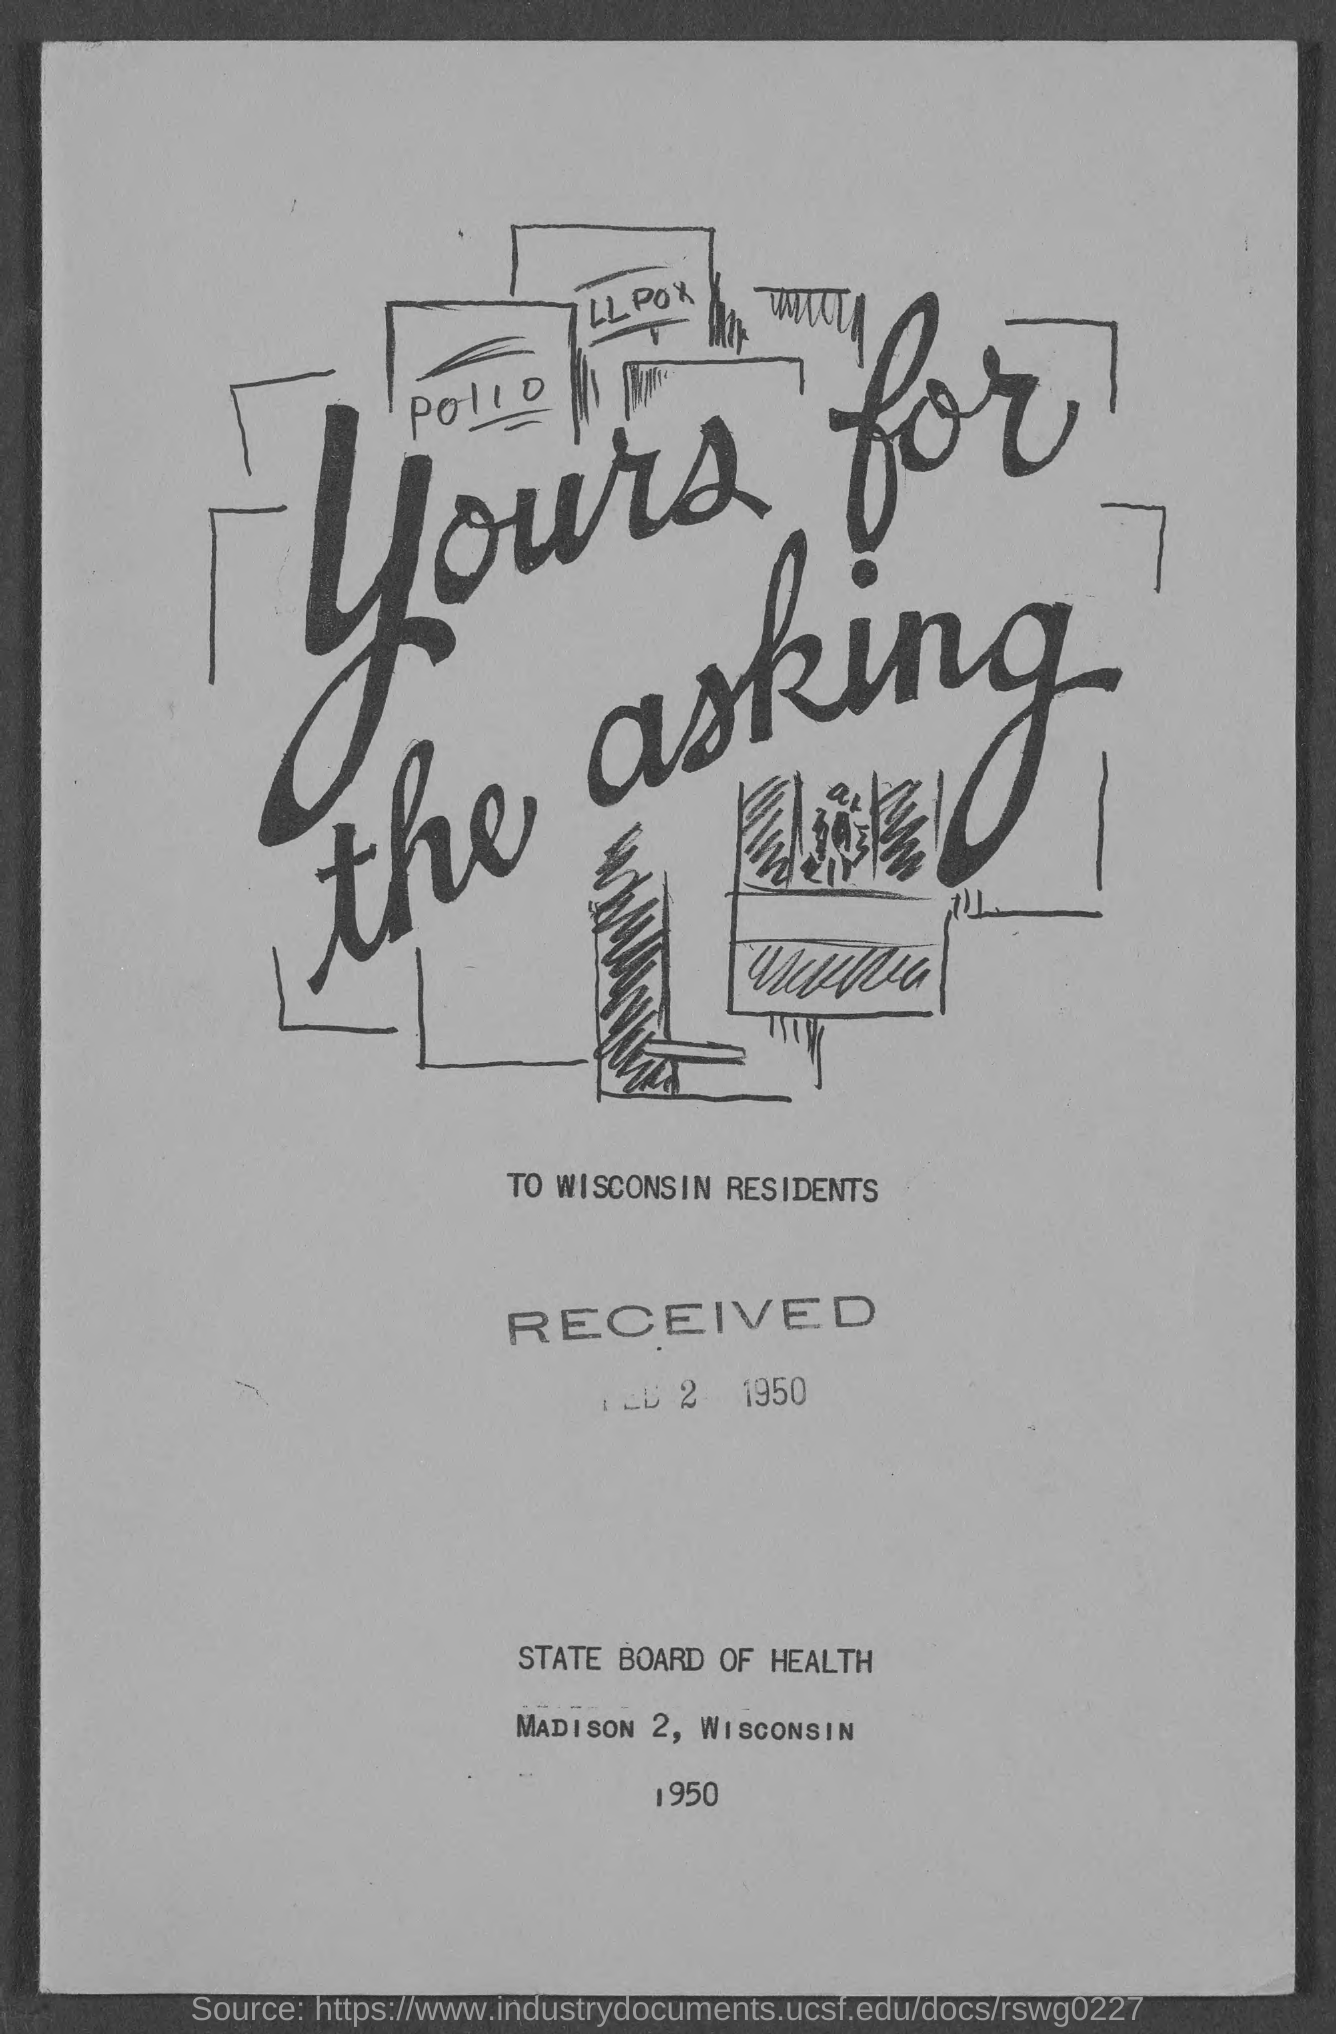Which residents are mentioned?
Give a very brief answer. WISCONSIN RESIDENTS. When was the document received?
Your response must be concise. FEB 2  1950. Which is the year mentioned at the bottom?
Provide a short and direct response. 1950. By which board is this document released?
Make the answer very short. STATE BOARD OF HEALTH. 